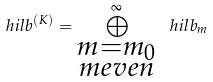<formula> <loc_0><loc_0><loc_500><loc_500>\ h i l b ^ { ( K ) } = \bigoplus _ { \substack { m = m _ { 0 } \\ m e v e n } } ^ { \infty } \ h i l b _ { m }</formula> 